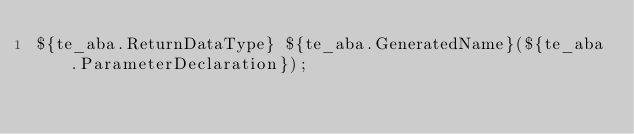<code> <loc_0><loc_0><loc_500><loc_500><_C_>${te_aba.ReturnDataType} ${te_aba.GeneratedName}(${te_aba.ParameterDeclaration});
</code> 